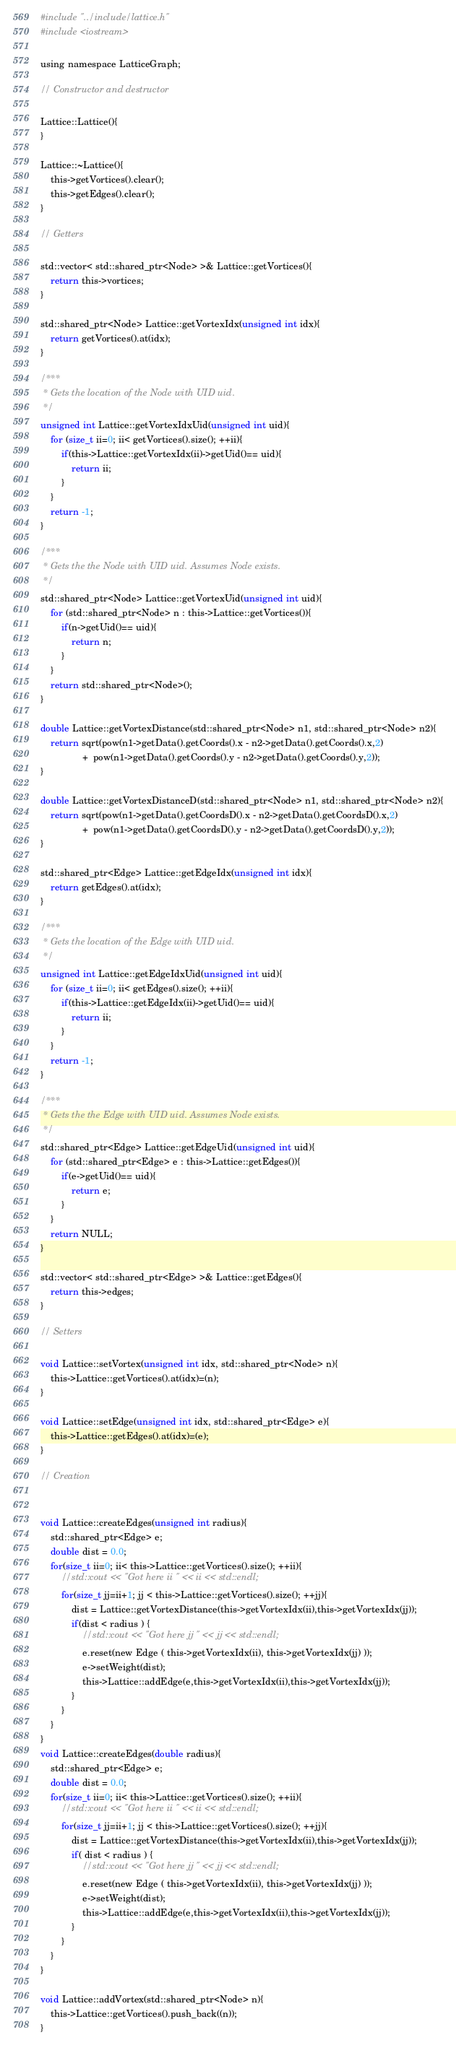<code> <loc_0><loc_0><loc_500><loc_500><_Cuda_>
#include "../include/lattice.h"
#include <iostream>

using namespace LatticeGraph;

// Constructor and destructor

Lattice::Lattice(){
}

Lattice::~Lattice(){
	this->getVortices().clear();
	this->getEdges().clear();
}

// Getters

std::vector< std::shared_ptr<Node> >& Lattice::getVortices(){
	return this->vortices;
}

std::shared_ptr<Node> Lattice::getVortexIdx(unsigned int idx){
	return getVortices().at(idx);
}

/***
 * Gets the location of the Node with UID uid.
 */
unsigned int Lattice::getVortexIdxUid(unsigned int uid){
	for (size_t ii=0; ii< getVortices().size(); ++ii){
		if(this->Lattice::getVortexIdx(ii)->getUid()== uid){
			return ii;
		}
	}
	return -1;
}

/***
 * Gets the the Node with UID uid. Assumes Node exists.
 */
std::shared_ptr<Node> Lattice::getVortexUid(unsigned int uid){
	for (std::shared_ptr<Node> n : this->Lattice::getVortices()){
		if(n->getUid()== uid){
			return n;
		}
	}
	return std::shared_ptr<Node>();
}

double Lattice::getVortexDistance(std::shared_ptr<Node> n1, std::shared_ptr<Node> n2){
	return sqrt(pow(n1->getData().getCoords().x - n2->getData().getCoords().x,2)
	            +  pow(n1->getData().getCoords().y - n2->getData().getCoords().y,2));
}

double Lattice::getVortexDistanceD(std::shared_ptr<Node> n1, std::shared_ptr<Node> n2){
	return sqrt(pow(n1->getData().getCoordsD().x - n2->getData().getCoordsD().x,2)
	            +  pow(n1->getData().getCoordsD().y - n2->getData().getCoordsD().y,2));
}

std::shared_ptr<Edge> Lattice::getEdgeIdx(unsigned int idx){
	return getEdges().at(idx);
}

/***
 * Gets the location of the Edge with UID uid.
 */
unsigned int Lattice::getEdgeIdxUid(unsigned int uid){
	for (size_t ii=0; ii< getEdges().size(); ++ii){
		if(this->Lattice::getEdgeIdx(ii)->getUid()== uid){
			return ii;
		}
	}
	return -1;
}

/***
 * Gets the the Edge with UID uid. Assumes Node exists.
 */
std::shared_ptr<Edge> Lattice::getEdgeUid(unsigned int uid){
	for (std::shared_ptr<Edge> e : this->Lattice::getEdges()){
		if(e->getUid()== uid){
			return e;
		}
	}
	return NULL;
}

std::vector< std::shared_ptr<Edge> >& Lattice::getEdges(){
	return this->edges;
}

// Setters

void Lattice::setVortex(unsigned int idx, std::shared_ptr<Node> n){
	this->Lattice::getVortices().at(idx)=(n);
}

void Lattice::setEdge(unsigned int idx, std::shared_ptr<Edge> e){
	this->Lattice::getEdges().at(idx)=(e);
}

// Creation


void Lattice::createEdges(unsigned int radius){
	std::shared_ptr<Edge> e;
	double dist = 0.0;
	for(size_t ii=0; ii< this->Lattice::getVortices().size(); ++ii){
		//std::cout << "Got here ii " << ii << std::endl;
		for(size_t jj=ii+1; jj < this->Lattice::getVortices().size(); ++jj){
			dist = Lattice::getVortexDistance(this->getVortexIdx(ii),this->getVortexIdx(jj));
			if(dist < radius ) {
				//std::cout << "Got here jj " << jj << std::endl;
				e.reset(new Edge ( this->getVortexIdx(ii), this->getVortexIdx(jj) ));
				e->setWeight(dist);
				this->Lattice::addEdge(e,this->getVortexIdx(ii),this->getVortexIdx(jj));
			}
		}
	}
}
void Lattice::createEdges(double radius){
	std::shared_ptr<Edge> e;
	double dist = 0.0;
	for(size_t ii=0; ii< this->Lattice::getVortices().size(); ++ii){
		//std::cout << "Got here ii " << ii << std::endl;
		for(size_t jj=ii+1; jj < this->Lattice::getVortices().size(); ++jj){
			dist = Lattice::getVortexDistance(this->getVortexIdx(ii),this->getVortexIdx(jj));
			if( dist < radius ) {
				//std::cout << "Got here jj " << jj << std::endl;
				e.reset(new Edge ( this->getVortexIdx(ii), this->getVortexIdx(jj) ));
				e->setWeight(dist);
				this->Lattice::addEdge(e,this->getVortexIdx(ii),this->getVortexIdx(jj));
			}
		}
	}
}

void Lattice::addVortex(std::shared_ptr<Node> n){
	this->Lattice::getVortices().push_back((n));
}
</code> 